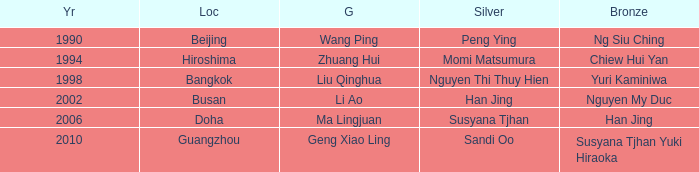What Gold has the Year of 2006? Ma Lingjuan. 